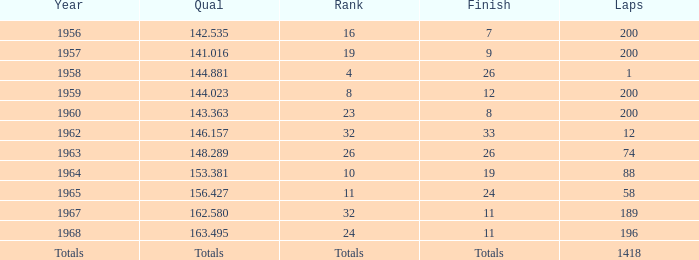What is the highest number of laps that also has a finish total of 8? 200.0. 